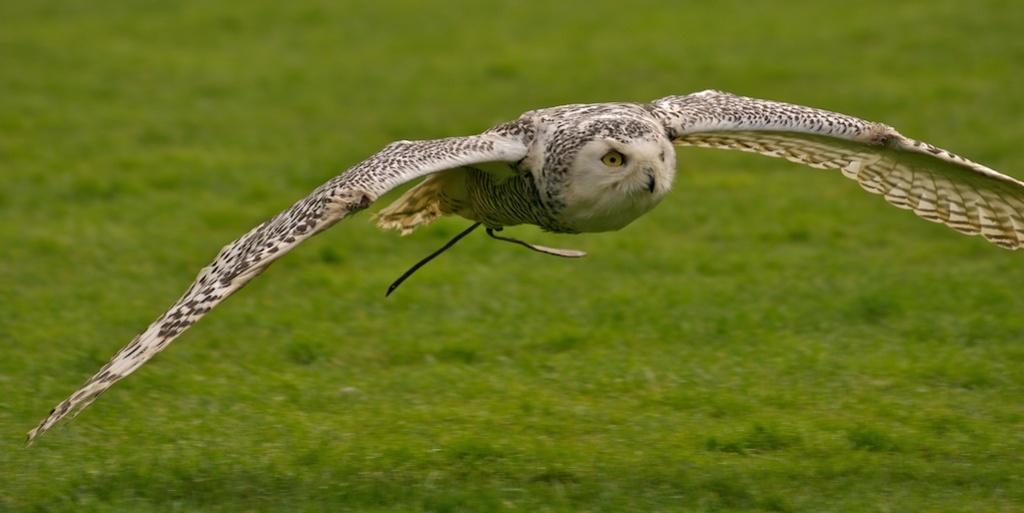What type of animal can be seen in the image? There is a bird in the image. What is the bird doing in the image? The bird is flying in the air. What can be seen below the bird in the image? There is a ground visible in the image. What type of loaf is the bird holding in the image? There is no loaf present in the image; the bird is simply flying. 